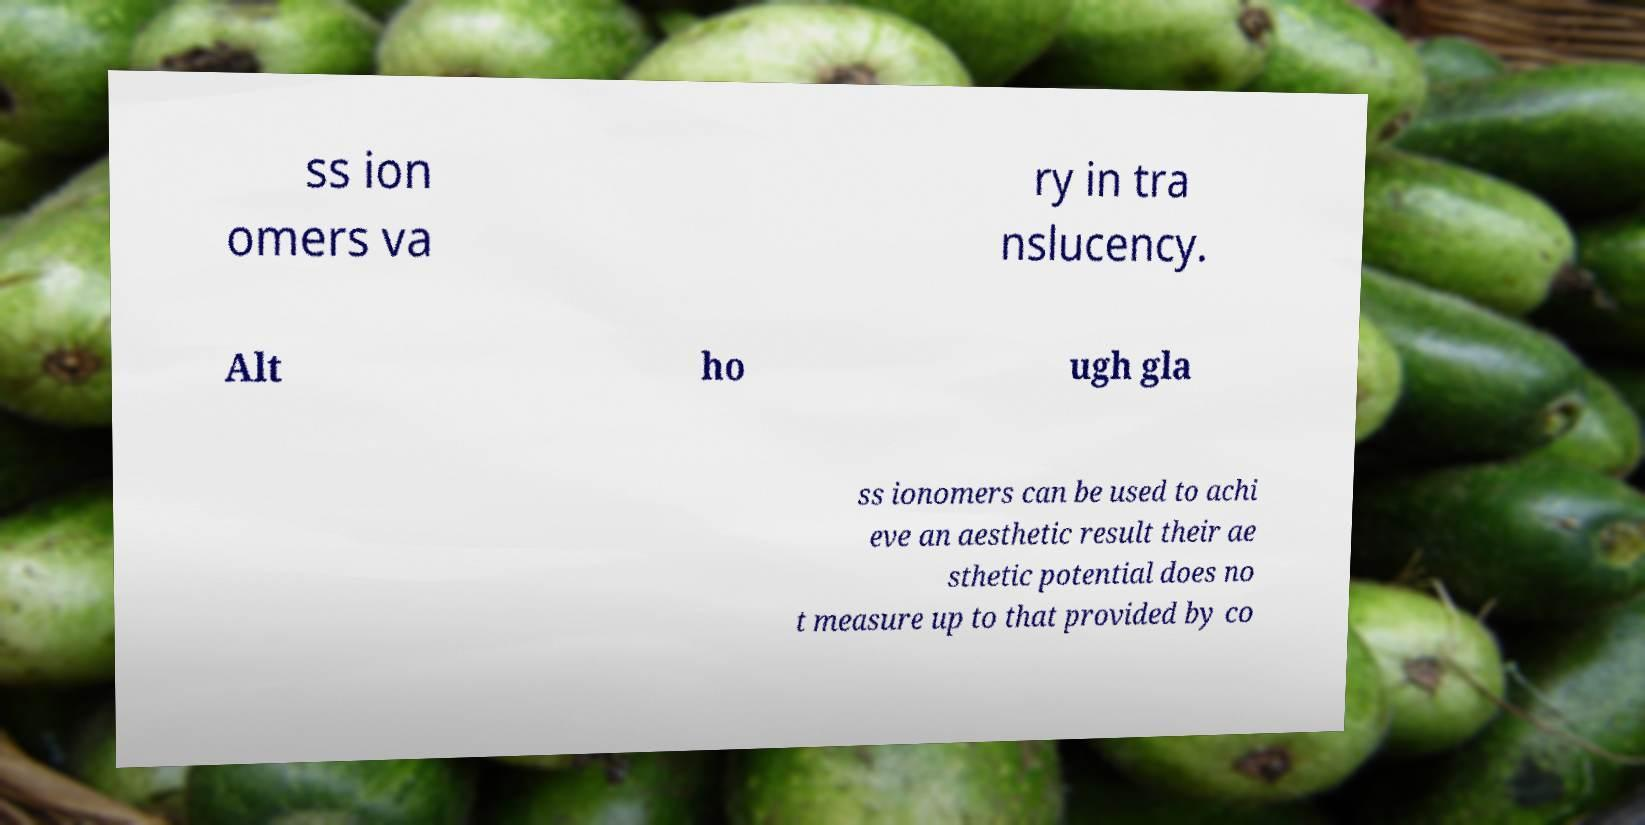For documentation purposes, I need the text within this image transcribed. Could you provide that? ss ion omers va ry in tra nslucency. Alt ho ugh gla ss ionomers can be used to achi eve an aesthetic result their ae sthetic potential does no t measure up to that provided by co 